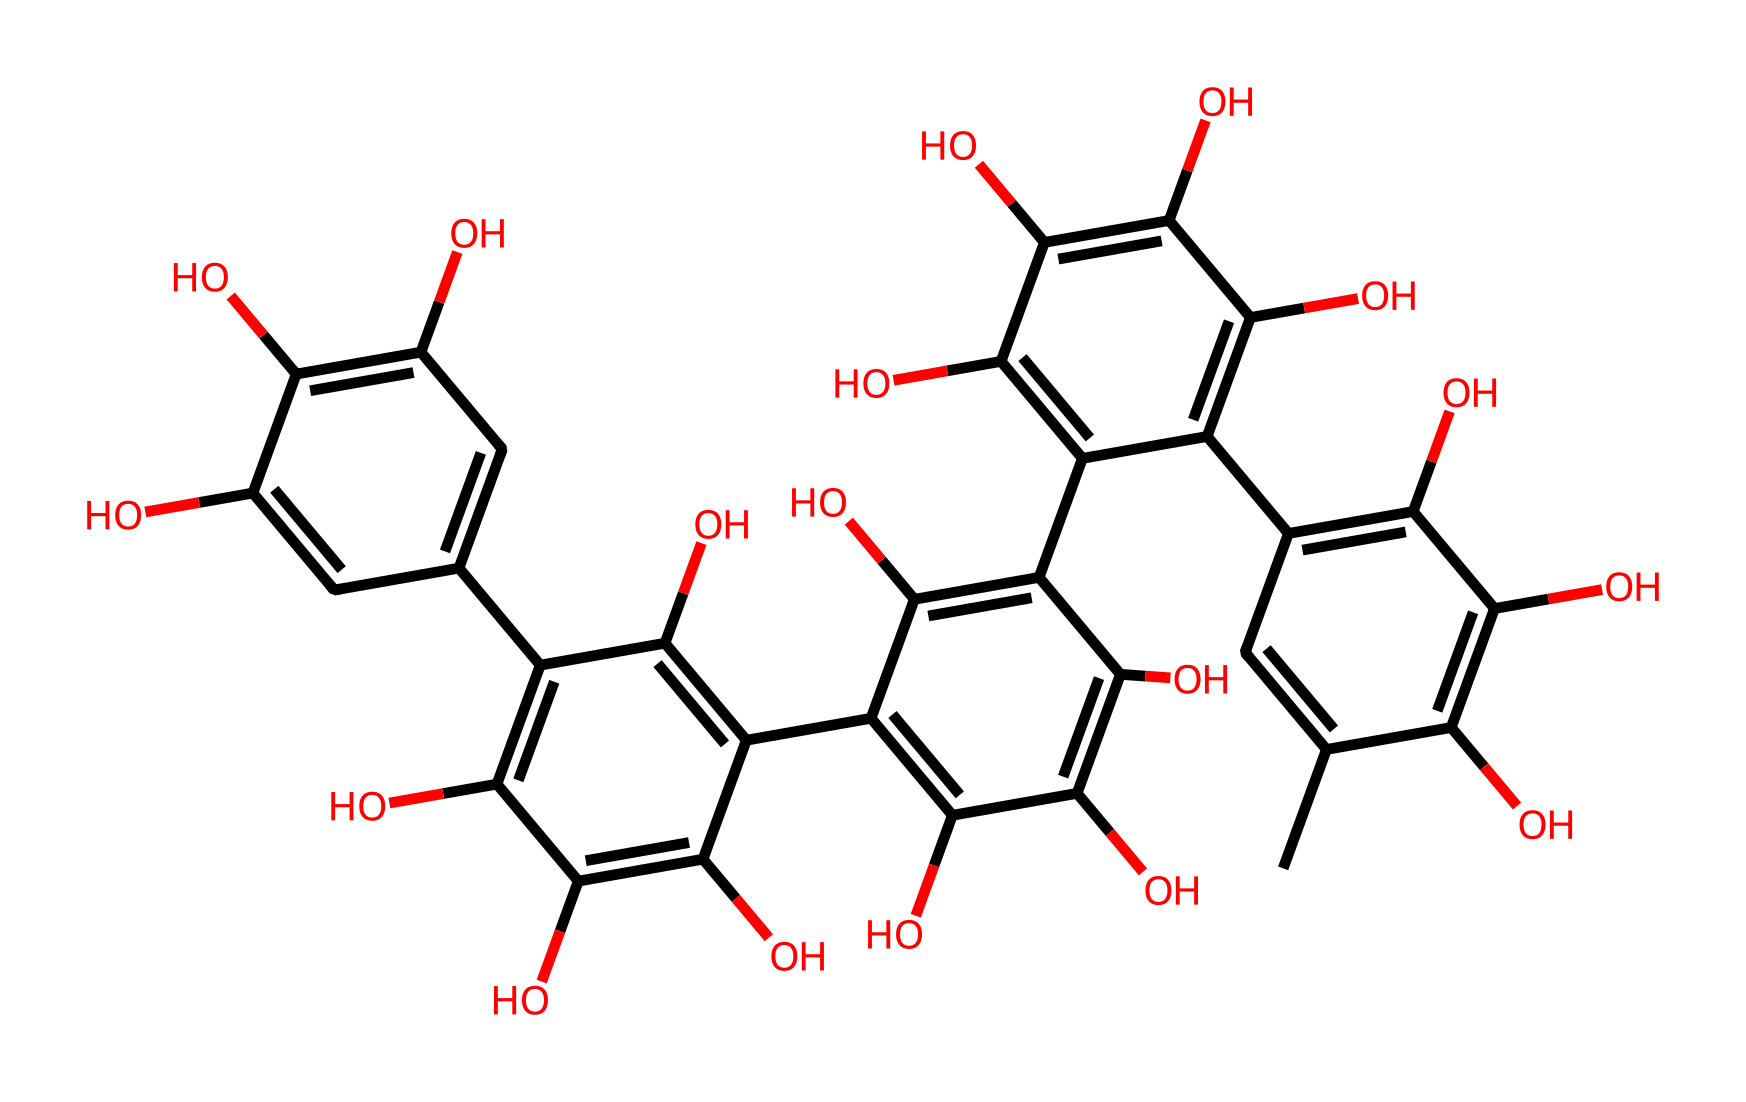What is the molecular formula of this tannin compound? The molecular formula can be derived by counting the number of each type of atom represented in the SMILES. From the structure, we can identify that there are 30 carbon (C) atoms, 32 hydrogen (H) atoms, and 10 oxygen (O) atoms, thus the molecular formula is C30H32O10.
Answer: C30H32O10 How many hydroxyl groups are present in this structure? Hydroxyl groups are indicated by the presence of -OH functional groups. By examining the SMILES notation, we can identify that there are 10 hydroxyl (-OH) groups attached to the carbon structure.
Answer: 10 What characteristic does the presence of multiple hydroxyl groups impart to this compound? Multiple hydroxyl groups are characteristic of polyphenols, which can confer properties such as water solubility and hydrogen bonding capabilities. The high number of hydroxyl groups suggests increased reactivity and the potential for forming complexes with metal ions.
Answer: Polyphenolic properties What is the likely solubility behavior of this compound in water? The presence of several hydroxyl groups typically enhances the solubility of the compound in water due to hydrogen bonding attraction between water molecules and the hydroxyl groups. Thus, this compound is likely to be soluble or partially soluble in water.
Answer: Likely soluble What does the cyclic structure in this tannin indicate about its stability? The presence of cyclic structures contributes to the compound's stability through resonance and the delocalization of electrons within the ring. The interconnected ring systems in tannins result in a stable overall structure.
Answer: Increased stability How might this tannin affect leather texture and durability in vintage military boots? Tannins, being non-electrolytes, play a crucial role in the tanning process, which enhances the leather's durability and texture by cross-linking collagen fibers, making it more resilient and less permeable to water.
Answer: Enhances durability and texture 